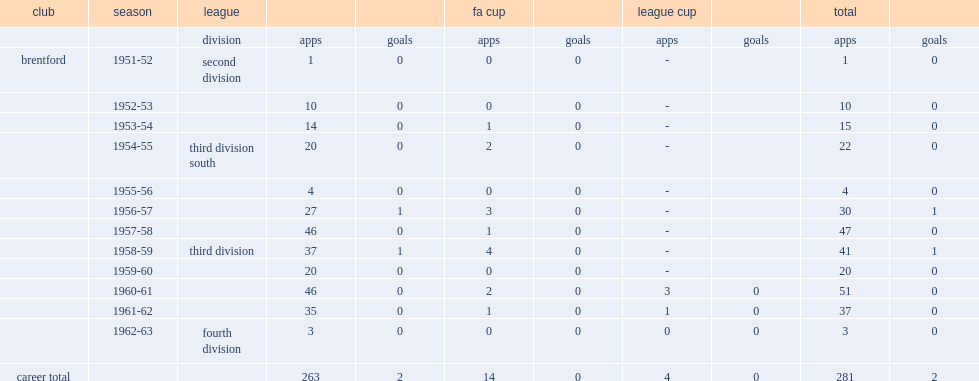Would you mind parsing the complete table? {'header': ['club', 'season', 'league', '', '', 'fa cup', '', 'league cup', '', 'total', ''], 'rows': [['', '', 'division', 'apps', 'goals', 'apps', 'goals', 'apps', 'goals', 'apps', 'goals'], ['brentford', '1951-52', 'second division', '1', '0', '0', '0', '-', '', '1', '0'], ['', '1952-53', '', '10', '0', '0', '0', '-', '', '10', '0'], ['', '1953-54', '', '14', '0', '1', '0', '-', '', '15', '0'], ['', '1954-55', 'third division south', '20', '0', '2', '0', '-', '', '22', '0'], ['', '1955-56', '', '4', '0', '0', '0', '-', '', '4', '0'], ['', '1956-57', '', '27', '1', '3', '0', '-', '', '30', '1'], ['', '1957-58', '', '46', '0', '1', '0', '-', '', '47', '0'], ['', '1958-59', 'third division', '37', '1', '4', '0', '-', '', '41', '1'], ['', '1959-60', '', '20', '0', '0', '0', '-', '', '20', '0'], ['', '1960-61', '', '46', '0', '2', '0', '3', '0', '51', '0'], ['', '1961-62', '', '35', '0', '1', '0', '1', '0', '37', '0'], ['', '1962-63', 'fourth division', '3', '0', '0', '0', '0', '0', '3', '0'], ['career total', '', '', '263', '2', '14', '0', '4', '0', '281', '2']]} How many goals did dargie score totally? 2.0. 